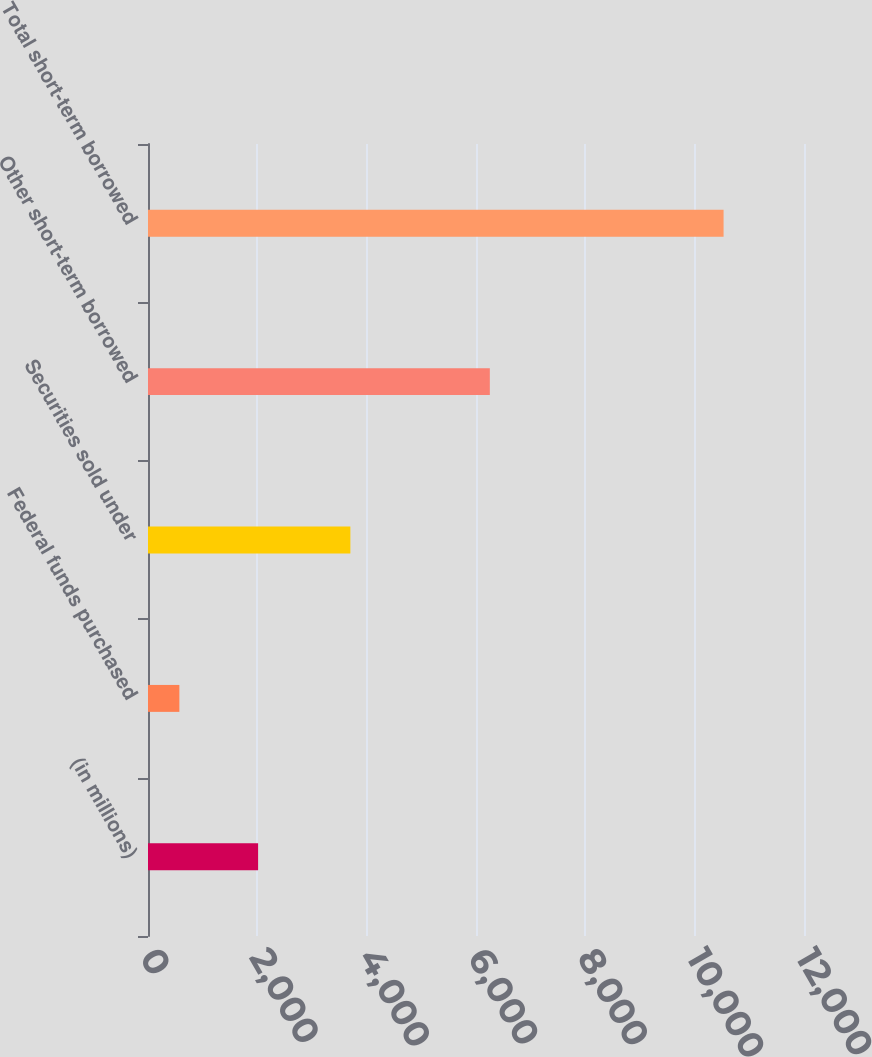Convert chart to OTSL. <chart><loc_0><loc_0><loc_500><loc_500><bar_chart><fcel>(in millions)<fcel>Federal funds purchased<fcel>Securities sold under<fcel>Other short-term borrowed<fcel>Total short-term borrowed<nl><fcel>2014<fcel>574<fcel>3702<fcel>6253<fcel>10529<nl></chart> 